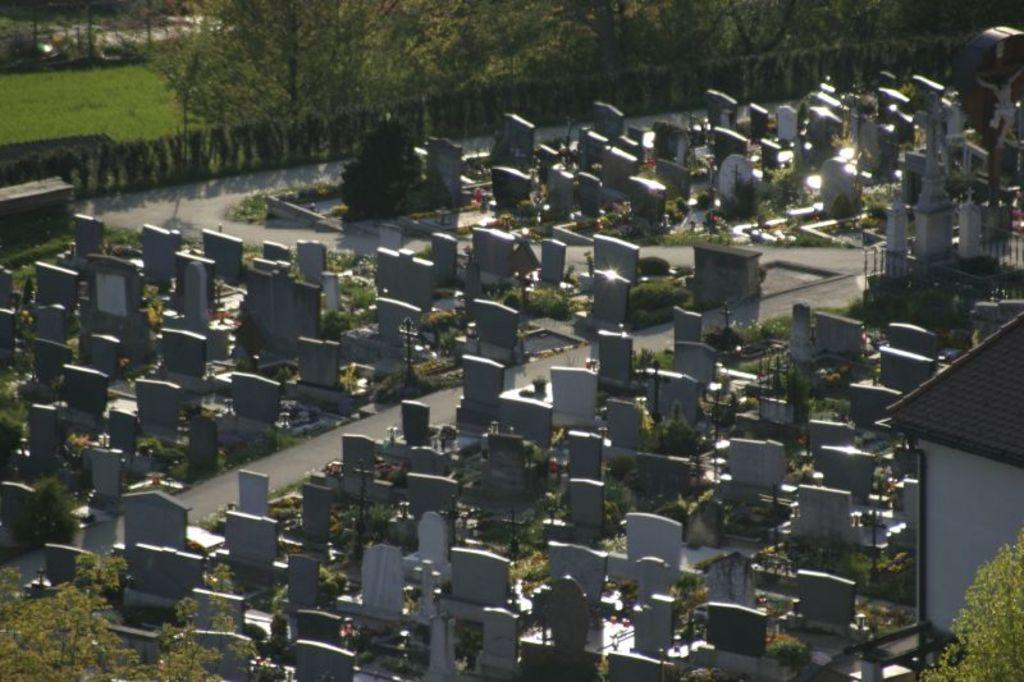What type of location is depicted in the image? The image appears to depict a graveyard. What can be seen in the middle of the image? There are graves in the middle of the image. What type of vegetation is visible at the top of the image? Trees are visible at the top of the image. What structure is located on the right side of the image? There is a house on the right side of the image. What type of rock is being used to roll in the image? There is no rock or rolling activity present in the image. How many beads are visible on the graves in the image? There are no beads visible on the graves in the image. 